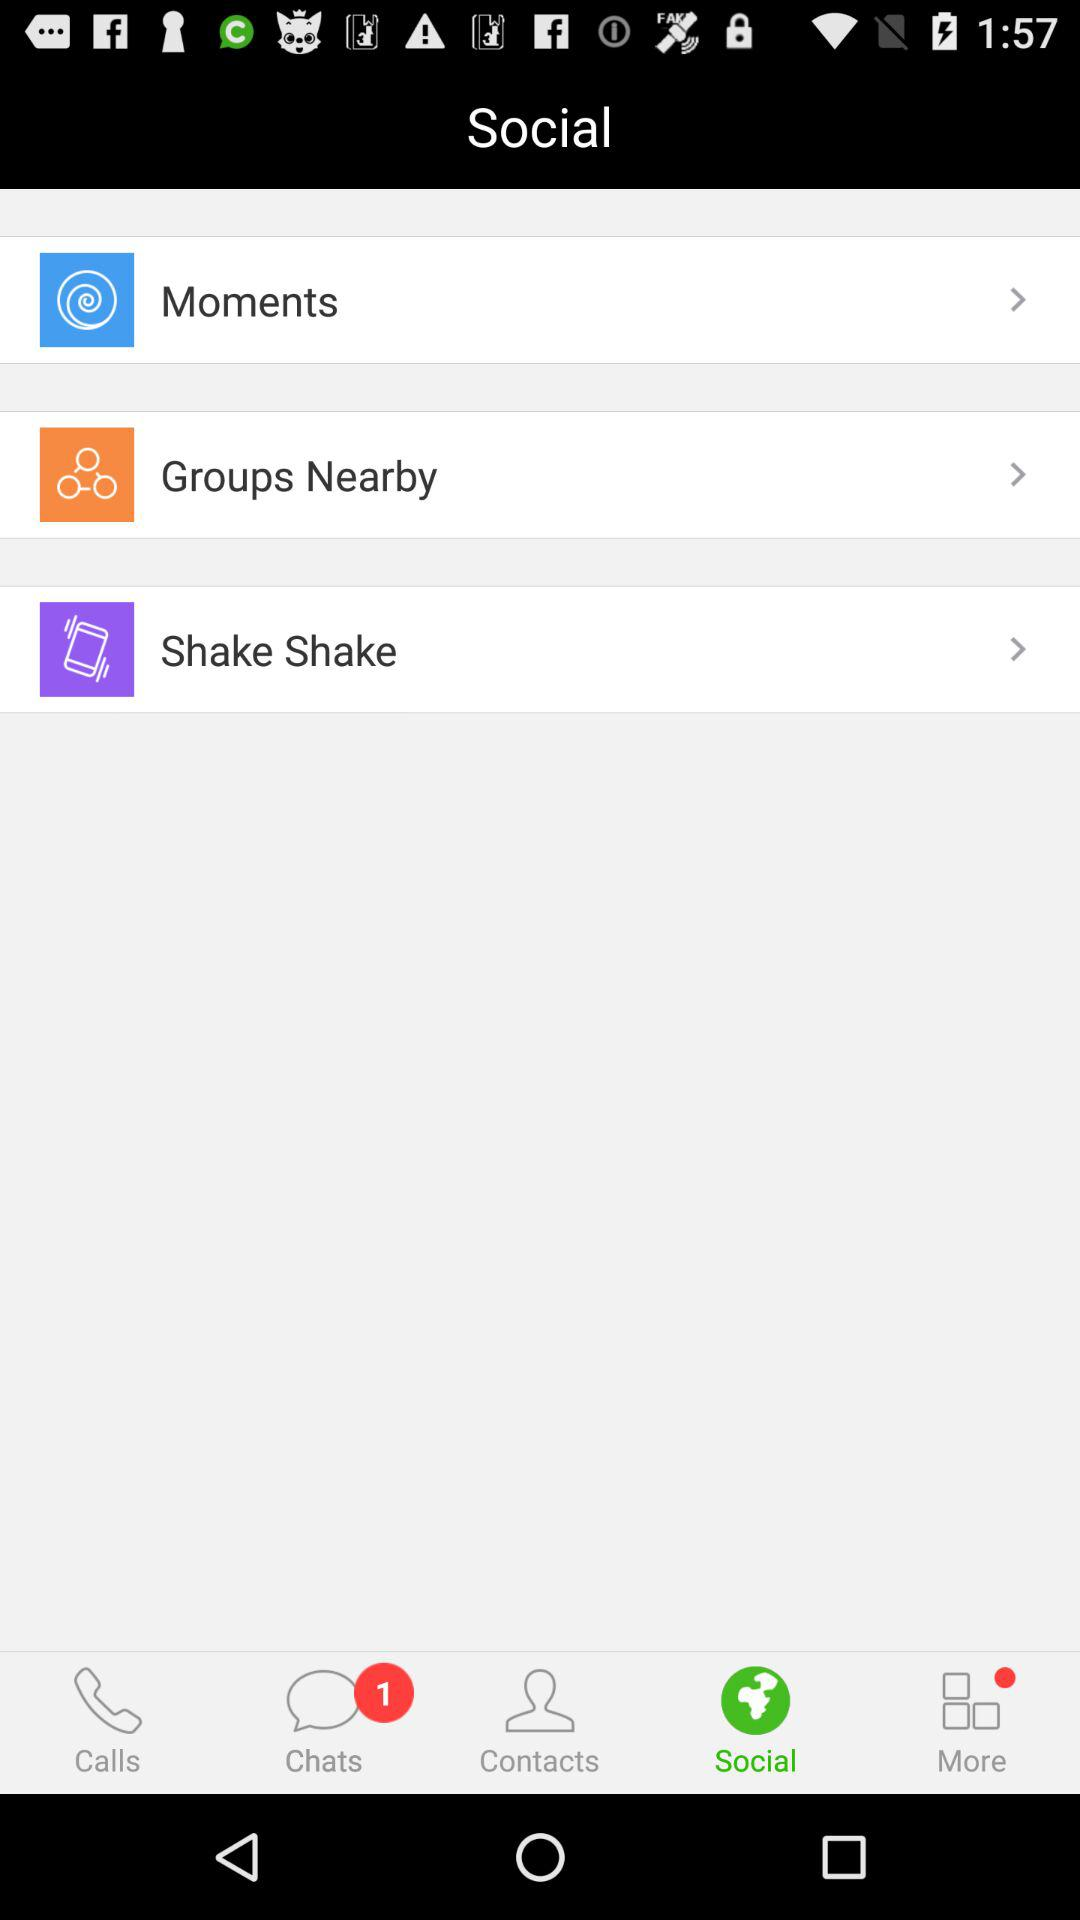Which tab is selected? The selected tab is "Social". 